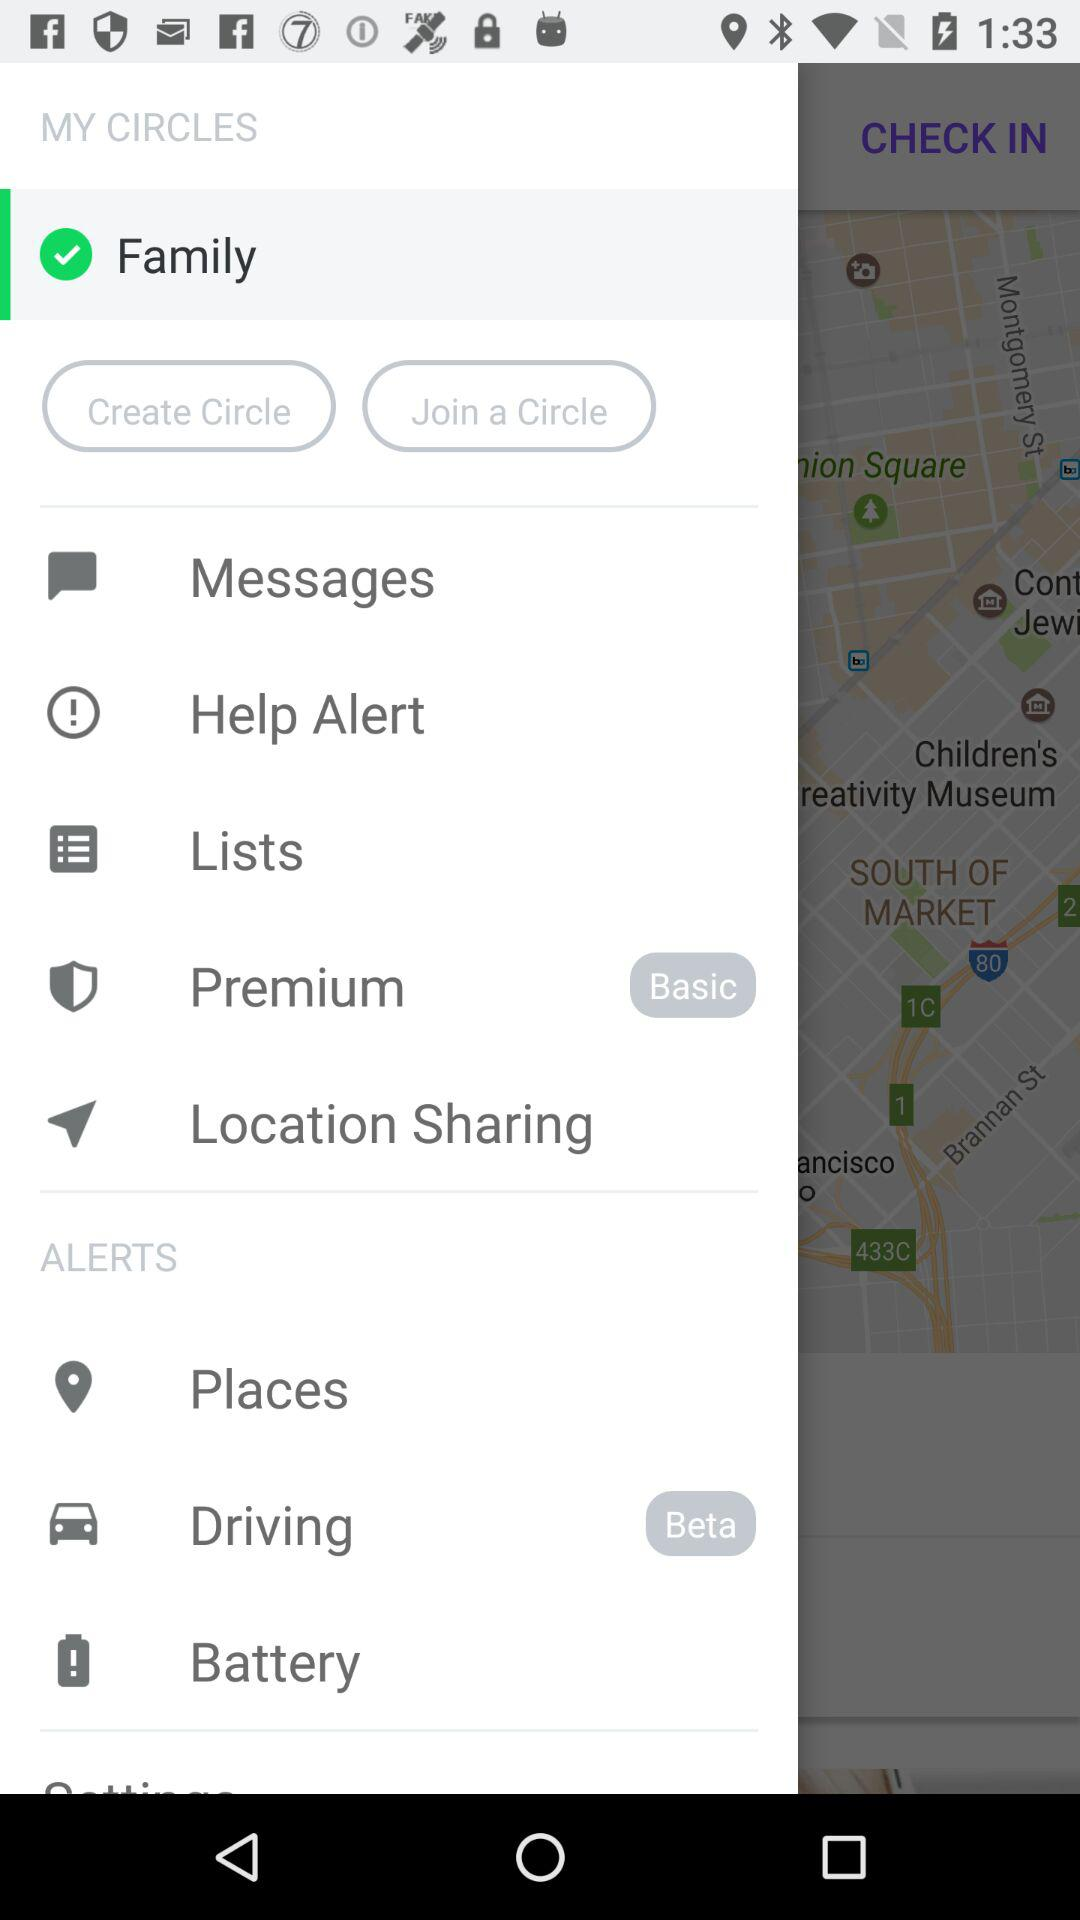What is the status of the "Family"? The status of the "Family" is "on". 